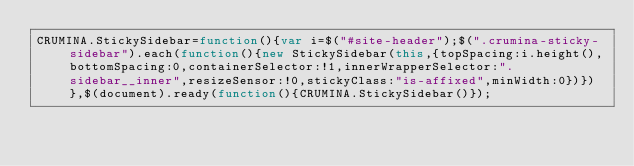<code> <loc_0><loc_0><loc_500><loc_500><_JavaScript_>CRUMINA.StickySidebar=function(){var i=$("#site-header");$(".crumina-sticky-sidebar").each(function(){new StickySidebar(this,{topSpacing:i.height(),bottomSpacing:0,containerSelector:!1,innerWrapperSelector:".sidebar__inner",resizeSensor:!0,stickyClass:"is-affixed",minWidth:0})})},$(document).ready(function(){CRUMINA.StickySidebar()});</code> 